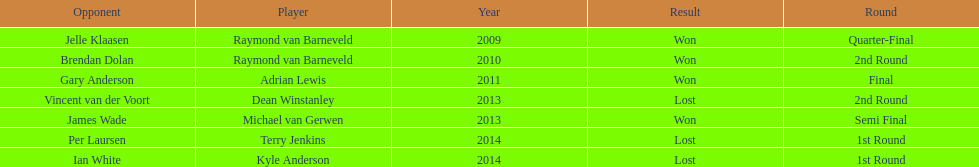Who won the first world darts championship? Raymond van Barneveld. 